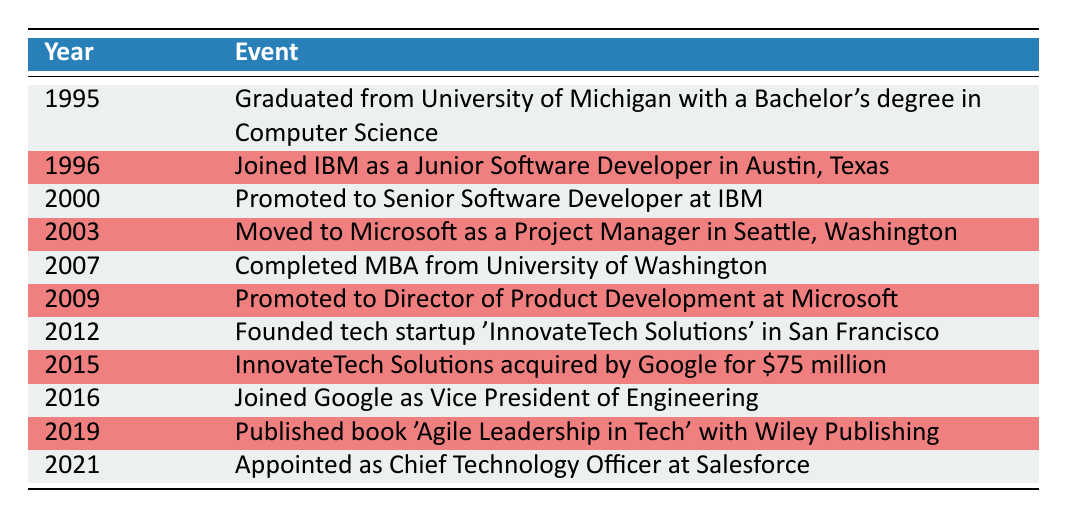What year did George graduate from college? The first entry in the timeline states that George graduated from the University of Michigan in 1995.
Answer: 1995 Which company did George join right after graduation? The timeline indicates that George joined IBM as a Junior Software Developer in 1996, the year following his graduation.
Answer: IBM How many years did George work at IBM before moving to Microsoft? George joined IBM in 1996 and moved to Microsoft in 2003. The difference between these two years is 2003 - 1996 = 7 years.
Answer: 7 years Did George complete his MBA before 2010? According to the timeline, George completed his MBA in 2007, which is indeed before 2010.
Answer: Yes What was George's role at Microsoft when he left the company? The timeline states that George was promoted to Director of Product Development at Microsoft in 2009, which is the last mention of his position there.
Answer: Director of Product Development How many years passed between the founding of InnovateTech Solutions and its acquisition by Google? InnovateTech Solutions was founded in 2012 and acquired by Google in 2015. The difference is 2015 - 2012 = 3 years.
Answer: 3 years Which event occurred in 2019? The timeline shows that in 2019, George published the book "Agile Leadership in Tech" with Wiley Publishing.
Answer: Published a book Did George hold a position at Google before becoming the CTO at Salesforce? The timeline indicates that George joined Google as Vice President of Engineering in 2016 and was later appointed as CTO at Salesforce in 2021, confirming he did hold a position at Google before that.
Answer: Yes What significant career milestone happened first: George's promotion to Senior Software Developer or his completion of an MBA? George was promoted to Senior Software Developer in 2000 and completed his MBA in 2007. Since 2000 is before 2007, his promotion happened first.
Answer: Promotion to Senior Software Developer 